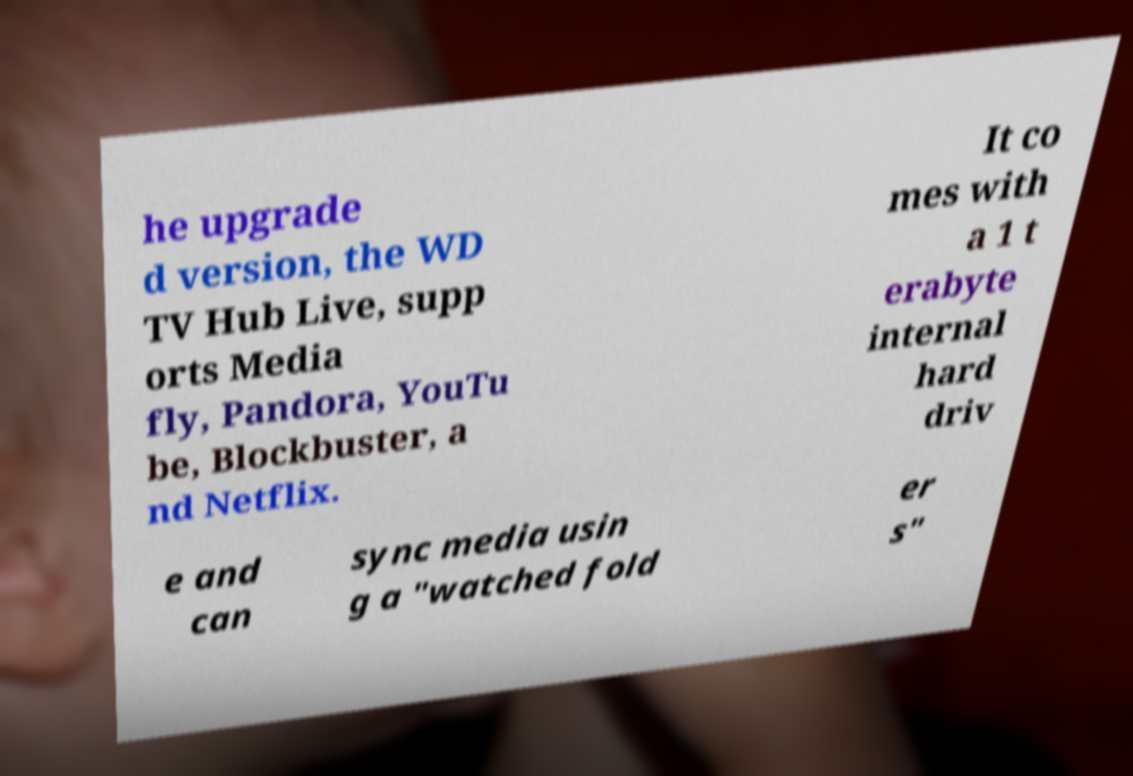Could you extract and type out the text from this image? he upgrade d version, the WD TV Hub Live, supp orts Media fly, Pandora, YouTu be, Blockbuster, a nd Netflix. It co mes with a 1 t erabyte internal hard driv e and can sync media usin g a "watched fold er s" 